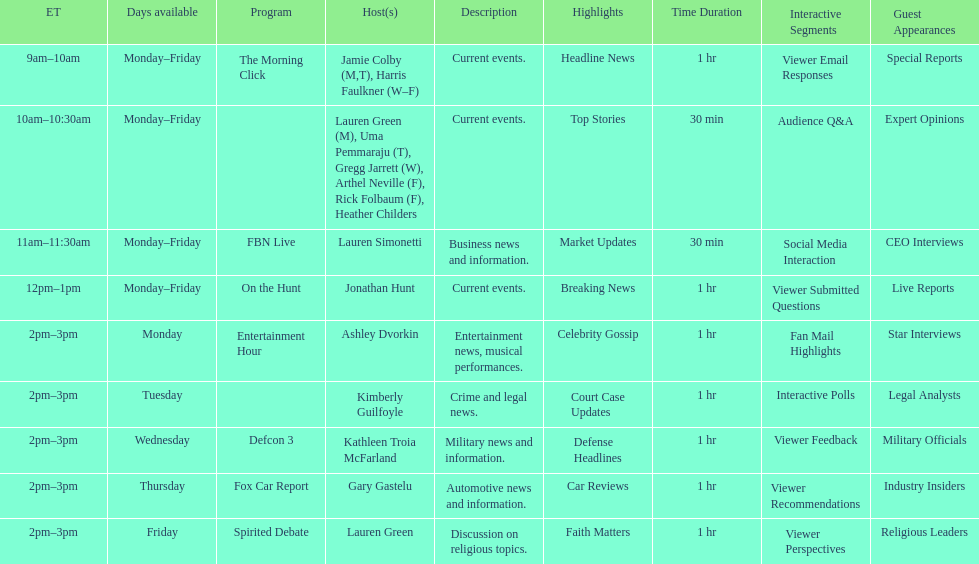Parse the full table. {'header': ['ET', 'Days available', 'Program', 'Host(s)', 'Description', 'Highlights', 'Time Duration', 'Interactive Segments', 'Guest Appearances'], 'rows': [['9am–10am', 'Monday–Friday', 'The Morning Click', 'Jamie Colby (M,T), Harris Faulkner (W–F)', 'Current events.', 'Headline News', '1 hr', 'Viewer Email Responses', 'Special Reports'], ['10am–10:30am', 'Monday–Friday', '', 'Lauren Green (M), Uma Pemmaraju (T), Gregg Jarrett (W), Arthel Neville (F), Rick Folbaum (F), Heather Childers', 'Current events.', 'Top Stories', '30 min', 'Audience Q&A', 'Expert Opinions'], ['11am–11:30am', 'Monday–Friday', 'FBN Live', 'Lauren Simonetti', 'Business news and information.', 'Market Updates', '30 min', 'Social Media Interaction', 'CEO Interviews'], ['12pm–1pm', 'Monday–Friday', 'On the Hunt', 'Jonathan Hunt', 'Current events.', 'Breaking News', '1 hr', 'Viewer Submitted Questions', 'Live Reports '], ['2pm–3pm', 'Monday', 'Entertainment Hour', 'Ashley Dvorkin', 'Entertainment news, musical performances.', 'Celebrity Gossip', '1 hr', 'Fan Mail Highlights', 'Star Interviews'], ['2pm–3pm', 'Tuesday', '', 'Kimberly Guilfoyle', 'Crime and legal news.', 'Court Case Updates', '1 hr', 'Interactive Polls', 'Legal Analysts'], ['2pm–3pm', 'Wednesday', 'Defcon 3', 'Kathleen Troia McFarland', 'Military news and information.', 'Defense Headlines', '1 hr', 'Viewer Feedback', 'Military Officials'], ['2pm–3pm', 'Thursday', 'Fox Car Report', 'Gary Gastelu', 'Automotive news and information.', 'Car Reviews', '1 hr', 'Viewer Recommendations', 'Industry Insiders'], ['2pm–3pm', 'Friday', 'Spirited Debate', 'Lauren Green', 'Discussion on religious topics.', 'Faith Matters', '1 hr', 'Viewer Perspectives', 'Religious Leaders']]} Which program is only available on thursdays? Fox Car Report. 